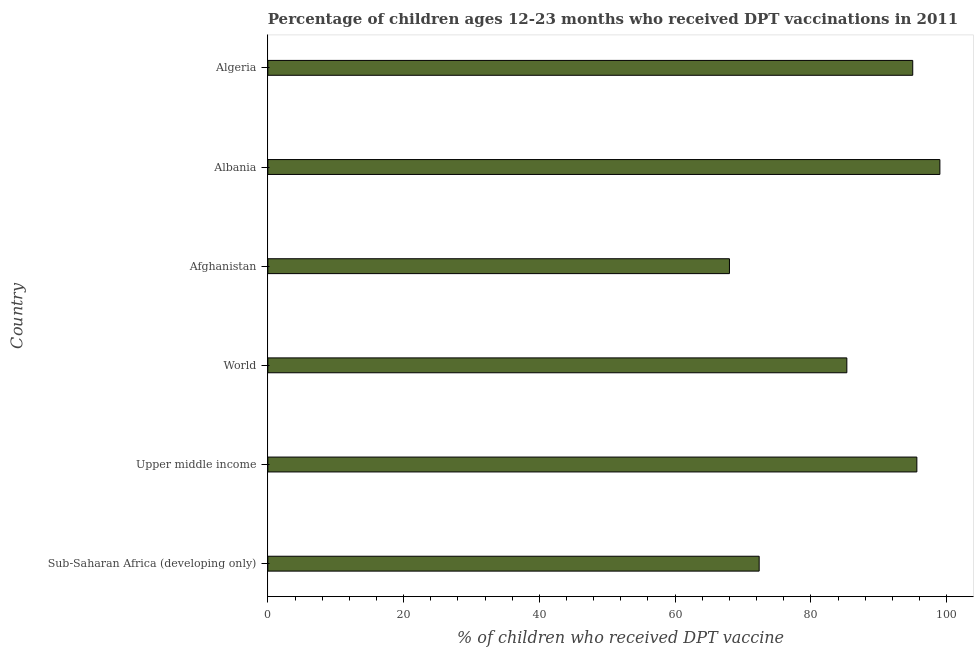What is the title of the graph?
Provide a succinct answer. Percentage of children ages 12-23 months who received DPT vaccinations in 2011. What is the label or title of the X-axis?
Keep it short and to the point. % of children who received DPT vaccine. What is the label or title of the Y-axis?
Provide a succinct answer. Country. In which country was the percentage of children who received dpt vaccine maximum?
Ensure brevity in your answer.  Albania. In which country was the percentage of children who received dpt vaccine minimum?
Offer a terse response. Afghanistan. What is the sum of the percentage of children who received dpt vaccine?
Ensure brevity in your answer.  515.28. What is the difference between the percentage of children who received dpt vaccine in Afghanistan and Albania?
Keep it short and to the point. -31. What is the average percentage of children who received dpt vaccine per country?
Your answer should be very brief. 85.88. What is the median percentage of children who received dpt vaccine?
Ensure brevity in your answer.  90.15. What is the ratio of the percentage of children who received dpt vaccine in Albania to that in Upper middle income?
Offer a terse response. 1.03. Is the percentage of children who received dpt vaccine in Afghanistan less than that in Sub-Saharan Africa (developing only)?
Offer a terse response. Yes. Is the difference between the percentage of children who received dpt vaccine in Algeria and World greater than the difference between any two countries?
Your response must be concise. No. What is the difference between the highest and the second highest percentage of children who received dpt vaccine?
Ensure brevity in your answer.  3.39. How many bars are there?
Ensure brevity in your answer.  6. What is the % of children who received DPT vaccine of Sub-Saharan Africa (developing only)?
Your answer should be very brief. 72.38. What is the % of children who received DPT vaccine in Upper middle income?
Ensure brevity in your answer.  95.61. What is the % of children who received DPT vaccine of World?
Make the answer very short. 85.29. What is the % of children who received DPT vaccine in Afghanistan?
Keep it short and to the point. 68. What is the % of children who received DPT vaccine in Albania?
Provide a short and direct response. 99. What is the difference between the % of children who received DPT vaccine in Sub-Saharan Africa (developing only) and Upper middle income?
Your answer should be very brief. -23.23. What is the difference between the % of children who received DPT vaccine in Sub-Saharan Africa (developing only) and World?
Give a very brief answer. -12.91. What is the difference between the % of children who received DPT vaccine in Sub-Saharan Africa (developing only) and Afghanistan?
Your response must be concise. 4.38. What is the difference between the % of children who received DPT vaccine in Sub-Saharan Africa (developing only) and Albania?
Make the answer very short. -26.62. What is the difference between the % of children who received DPT vaccine in Sub-Saharan Africa (developing only) and Algeria?
Offer a terse response. -22.62. What is the difference between the % of children who received DPT vaccine in Upper middle income and World?
Provide a succinct answer. 10.31. What is the difference between the % of children who received DPT vaccine in Upper middle income and Afghanistan?
Provide a short and direct response. 27.61. What is the difference between the % of children who received DPT vaccine in Upper middle income and Albania?
Provide a succinct answer. -3.39. What is the difference between the % of children who received DPT vaccine in Upper middle income and Algeria?
Give a very brief answer. 0.61. What is the difference between the % of children who received DPT vaccine in World and Afghanistan?
Ensure brevity in your answer.  17.29. What is the difference between the % of children who received DPT vaccine in World and Albania?
Provide a succinct answer. -13.71. What is the difference between the % of children who received DPT vaccine in World and Algeria?
Your answer should be compact. -9.71. What is the difference between the % of children who received DPT vaccine in Afghanistan and Albania?
Your response must be concise. -31. What is the ratio of the % of children who received DPT vaccine in Sub-Saharan Africa (developing only) to that in Upper middle income?
Make the answer very short. 0.76. What is the ratio of the % of children who received DPT vaccine in Sub-Saharan Africa (developing only) to that in World?
Your answer should be compact. 0.85. What is the ratio of the % of children who received DPT vaccine in Sub-Saharan Africa (developing only) to that in Afghanistan?
Offer a terse response. 1.06. What is the ratio of the % of children who received DPT vaccine in Sub-Saharan Africa (developing only) to that in Albania?
Offer a very short reply. 0.73. What is the ratio of the % of children who received DPT vaccine in Sub-Saharan Africa (developing only) to that in Algeria?
Make the answer very short. 0.76. What is the ratio of the % of children who received DPT vaccine in Upper middle income to that in World?
Provide a succinct answer. 1.12. What is the ratio of the % of children who received DPT vaccine in Upper middle income to that in Afghanistan?
Your answer should be compact. 1.41. What is the ratio of the % of children who received DPT vaccine in World to that in Afghanistan?
Provide a succinct answer. 1.25. What is the ratio of the % of children who received DPT vaccine in World to that in Albania?
Keep it short and to the point. 0.86. What is the ratio of the % of children who received DPT vaccine in World to that in Algeria?
Your answer should be very brief. 0.9. What is the ratio of the % of children who received DPT vaccine in Afghanistan to that in Albania?
Make the answer very short. 0.69. What is the ratio of the % of children who received DPT vaccine in Afghanistan to that in Algeria?
Offer a very short reply. 0.72. What is the ratio of the % of children who received DPT vaccine in Albania to that in Algeria?
Make the answer very short. 1.04. 